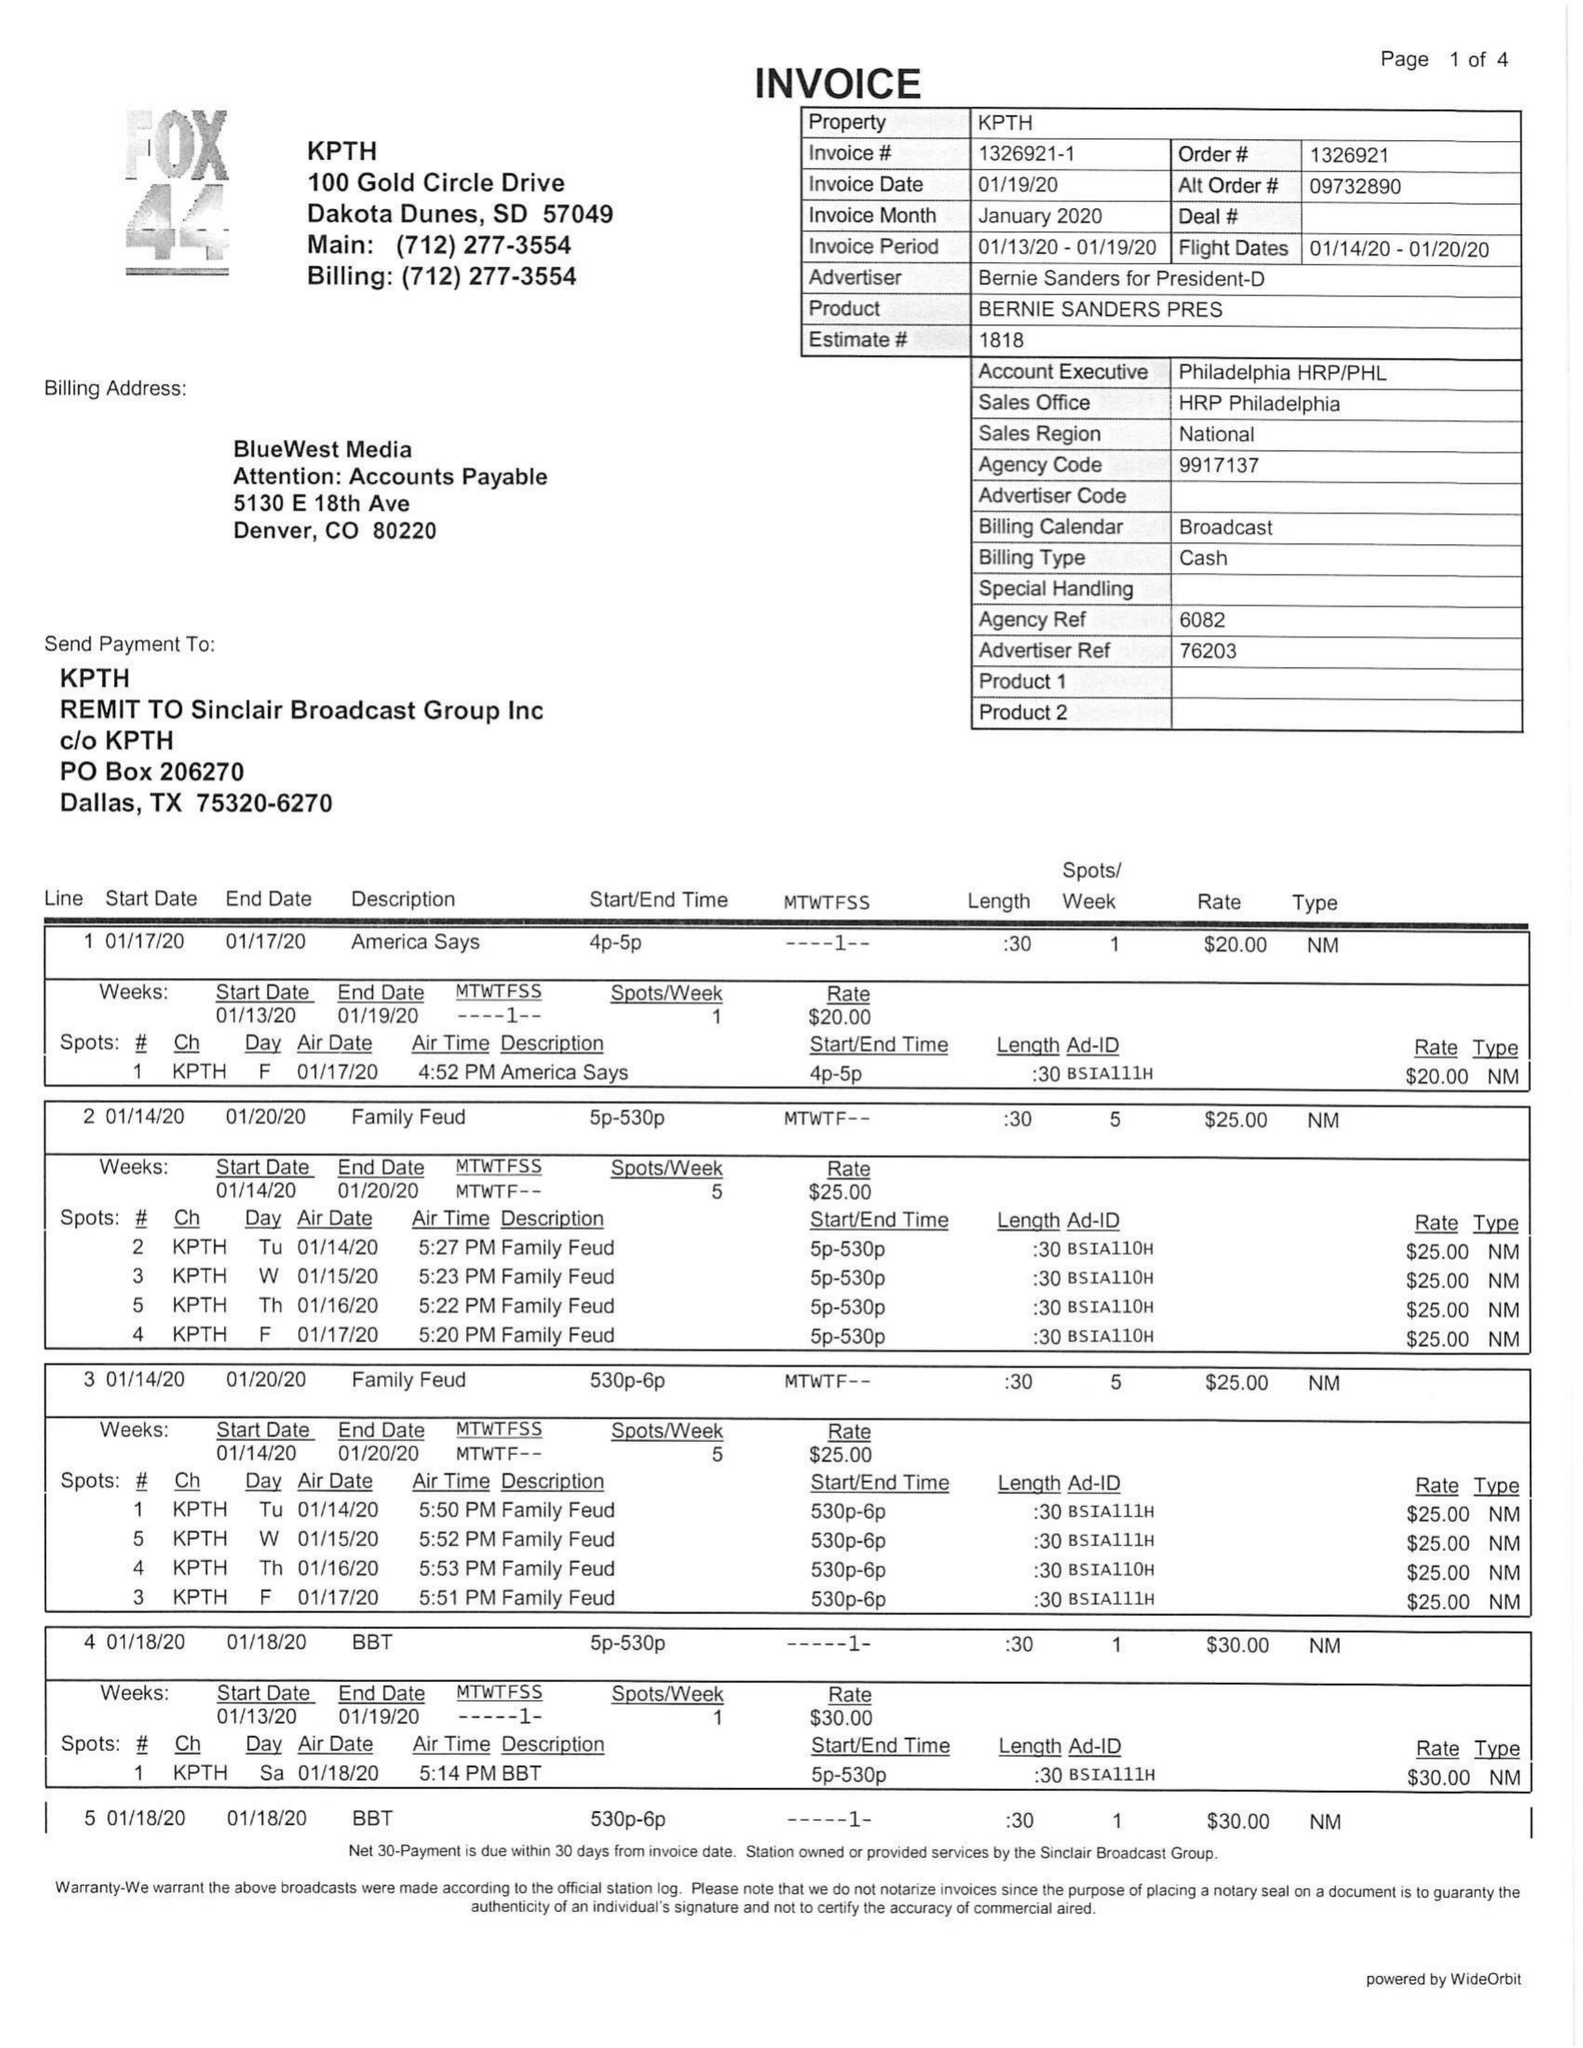What is the value for the advertiser?
Answer the question using a single word or phrase. BERNIE SANDERS FOR PRESIDENT-D 